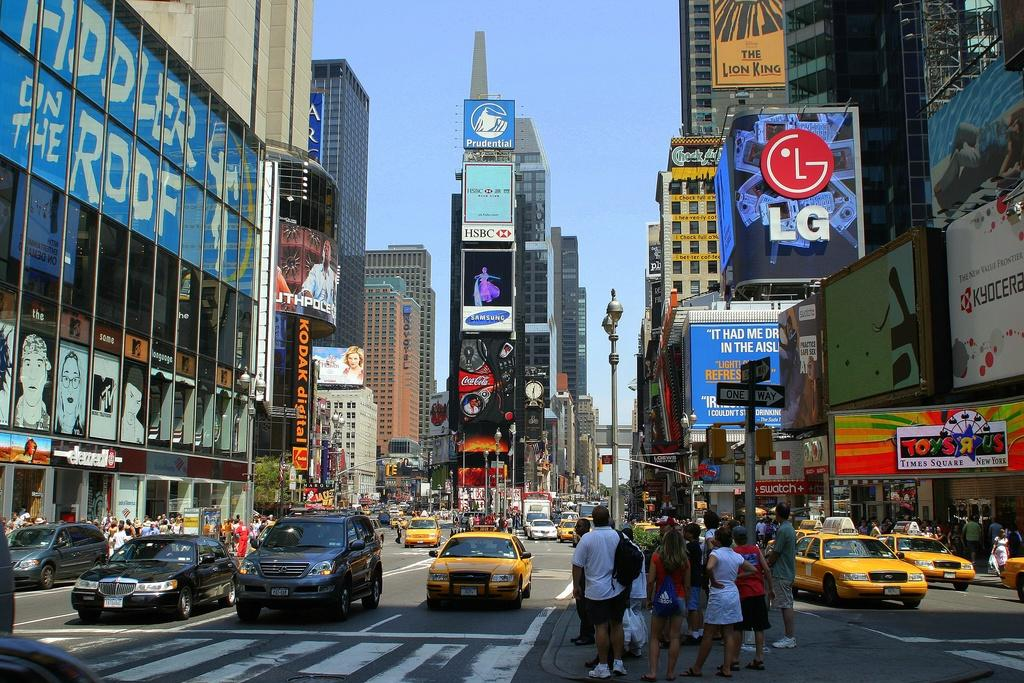<image>
Offer a succinct explanation of the picture presented. A city street has a sign in building windows to the left for Fiddler on the Roof;  The lower left shows the entrance to Toys R Us Times Square. 